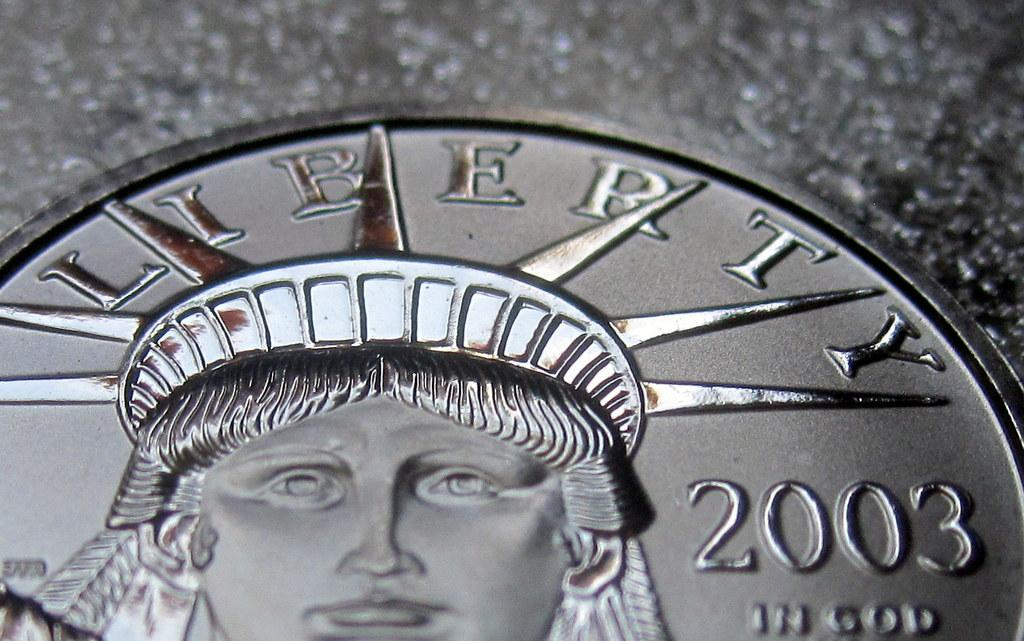Provide a one-sentence caption for the provided image. Silver coin that has the year 2003 on the right. 